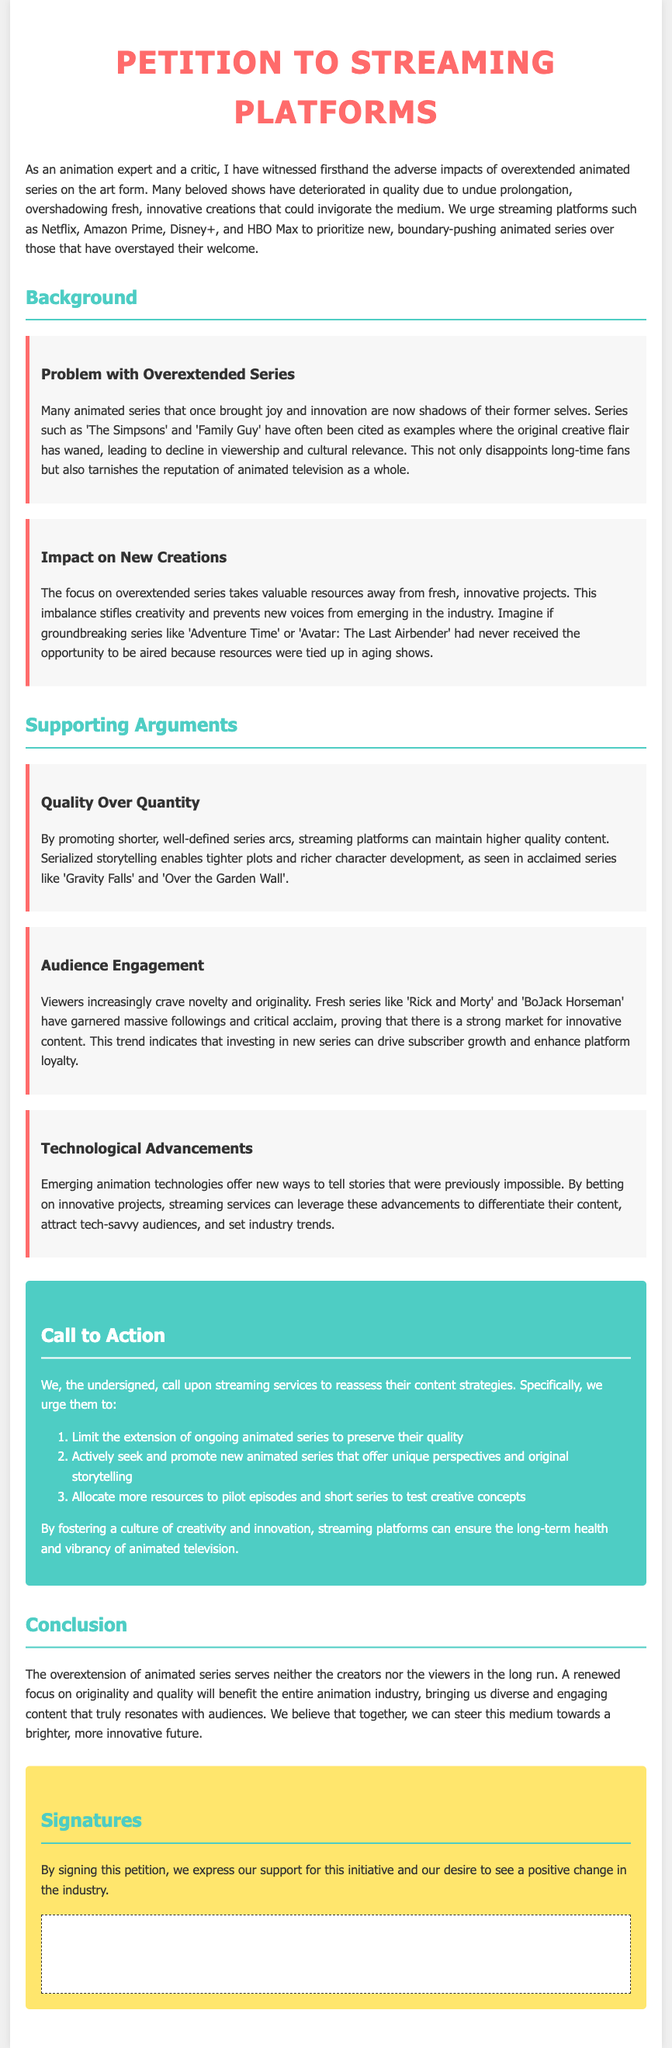What is the main purpose of the petition? The petition aims to urge streaming platforms to prioritize new, innovative animated series over overextended ones.
Answer: To promote fresh animated series What platforms are addressed in the petition? The petition specifically mentions Netflix, Amazon Prime, Disney+, and HBO Max as streaming platforms.
Answer: Netflix, Amazon Prime, Disney+, HBO Max What is one example mentioned of an overextended animated series? 'The Simpsons' is cited as a classic example of an animated series that has lost its original creative flair due to overextension.
Answer: The Simpsons What is emphasized as a benefit of promoting shorter series? The petition states that promoting shorter series can maintain higher quality content through serialized storytelling.
Answer: Higher quality content What does the call to action urge streaming services to do? The petition urges streaming services to limit the extension of animated series and promote new ones.
Answer: Limit the extension of ongoing series How does the document describe the impact of resource allocation on new projects? The document explains that focusing on overextended series stifles creativity and prevents new voices from emerging.
Answer: Stifles creativity Which two series are highlighted as examples of successful, innovative content? 'Rick and Morty' and 'BoJack Horseman' are mentioned as fresh series that have garnered massive followings and critical acclaim.
Answer: Rick and Morty, BoJack Horseman What overarching theme is conveyed in the conclusion? The conclusion conveys that a renewed focus on originality and quality will benefit the animation industry as a whole.
Answer: Originality and quality Who is encouraged to sign the petition? The petition is directed at anyone who supports the initiative for positive change in the animation industry.
Answer: The undersigned 